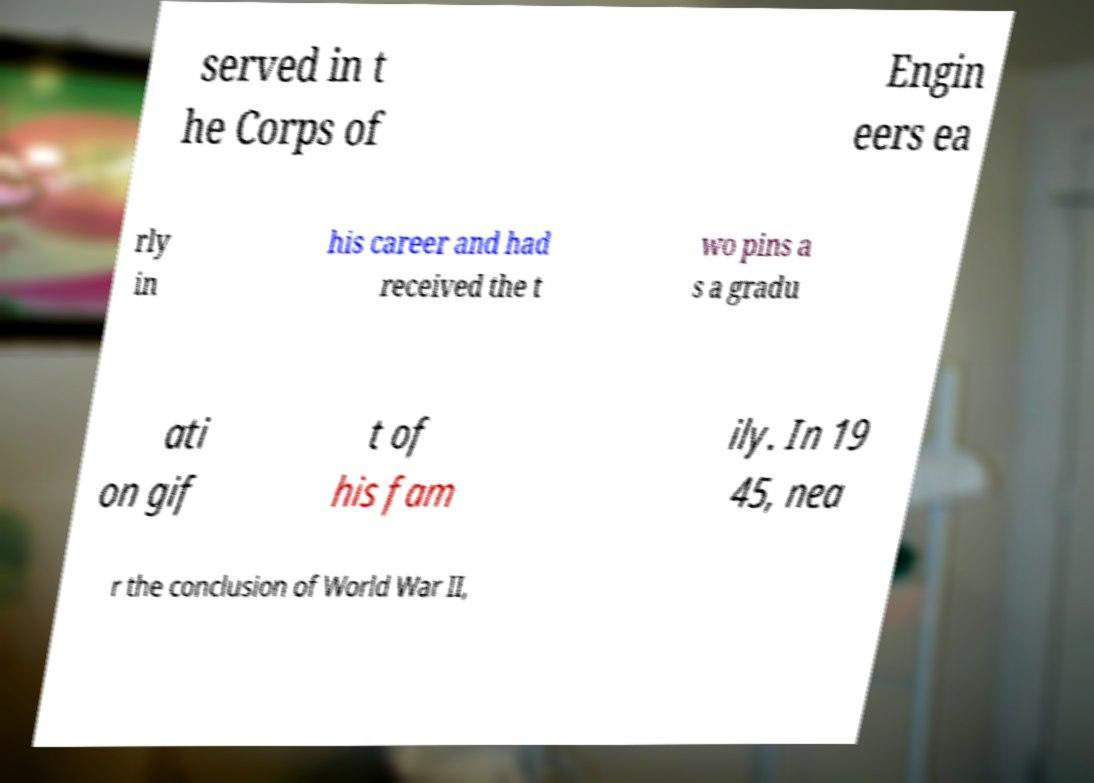Can you accurately transcribe the text from the provided image for me? served in t he Corps of Engin eers ea rly in his career and had received the t wo pins a s a gradu ati on gif t of his fam ily. In 19 45, nea r the conclusion of World War II, 